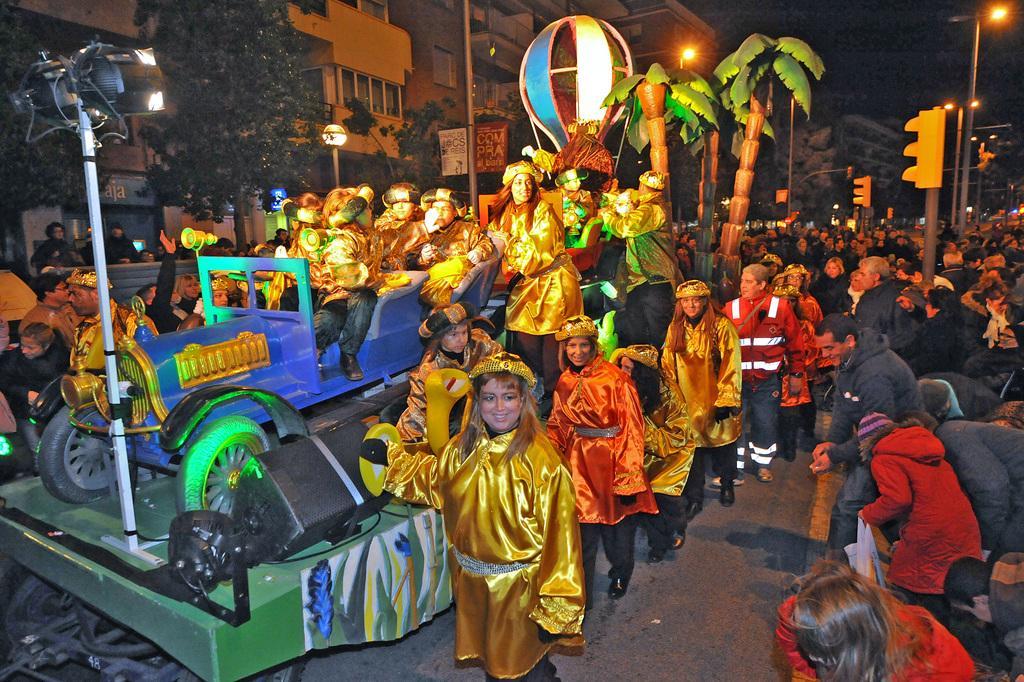Describe this image in one or two sentences. In this image I can see some people. On the right side, I can see a vehicle, the trees and the buildings. At the top I can see the lights. 